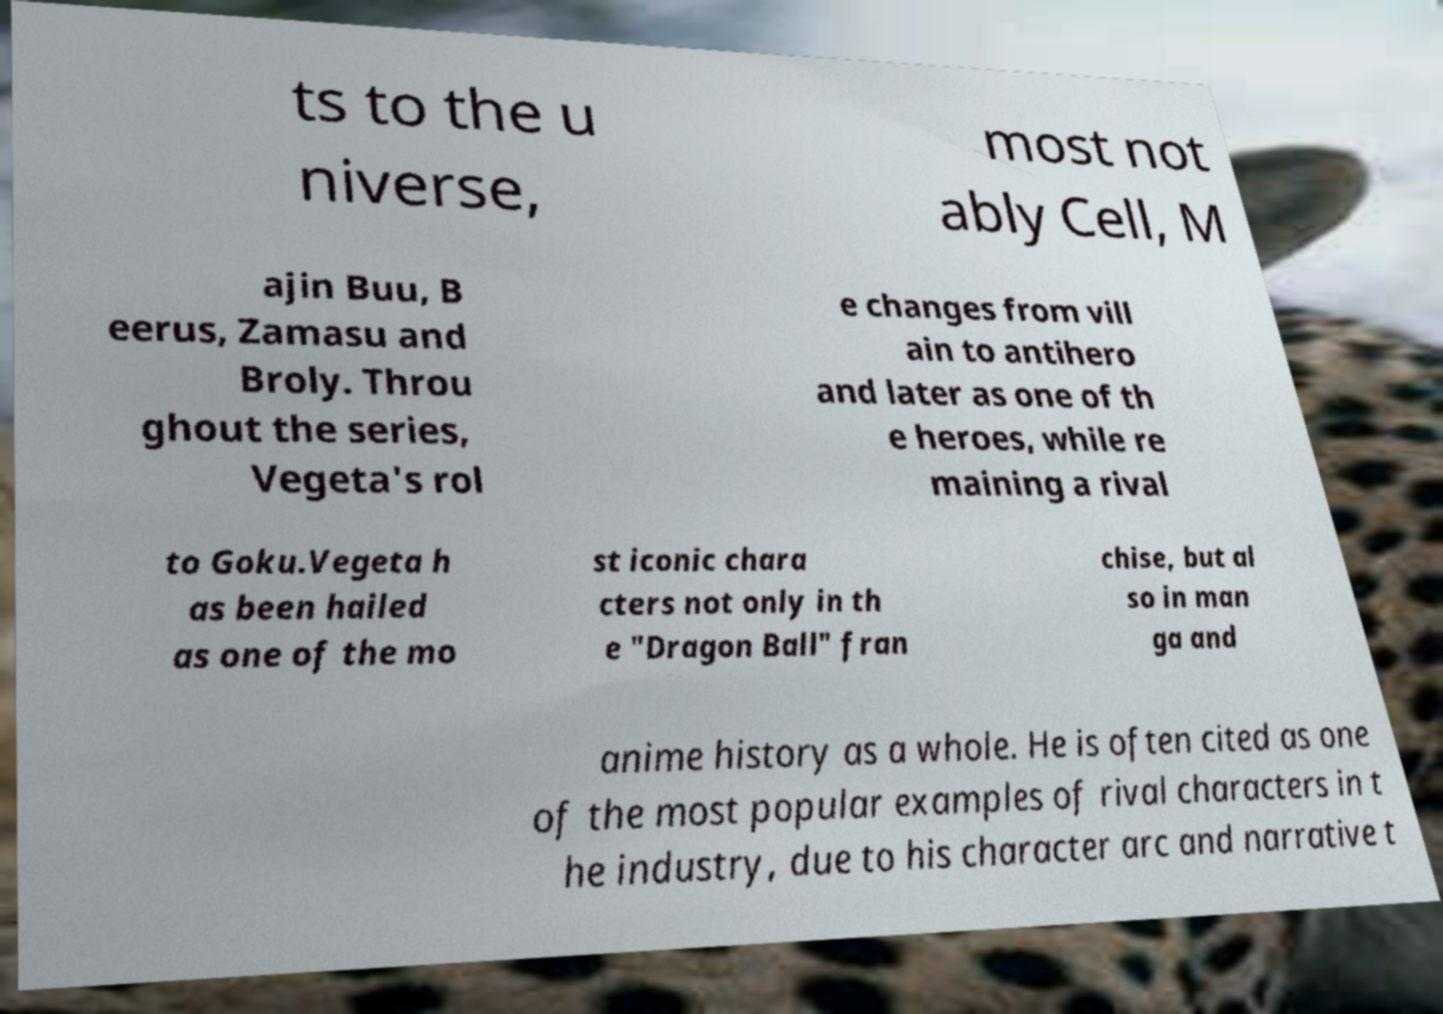Can you accurately transcribe the text from the provided image for me? ts to the u niverse, most not ably Cell, M ajin Buu, B eerus, Zamasu and Broly. Throu ghout the series, Vegeta's rol e changes from vill ain to antihero and later as one of th e heroes, while re maining a rival to Goku.Vegeta h as been hailed as one of the mo st iconic chara cters not only in th e "Dragon Ball" fran chise, but al so in man ga and anime history as a whole. He is often cited as one of the most popular examples of rival characters in t he industry, due to his character arc and narrative t 